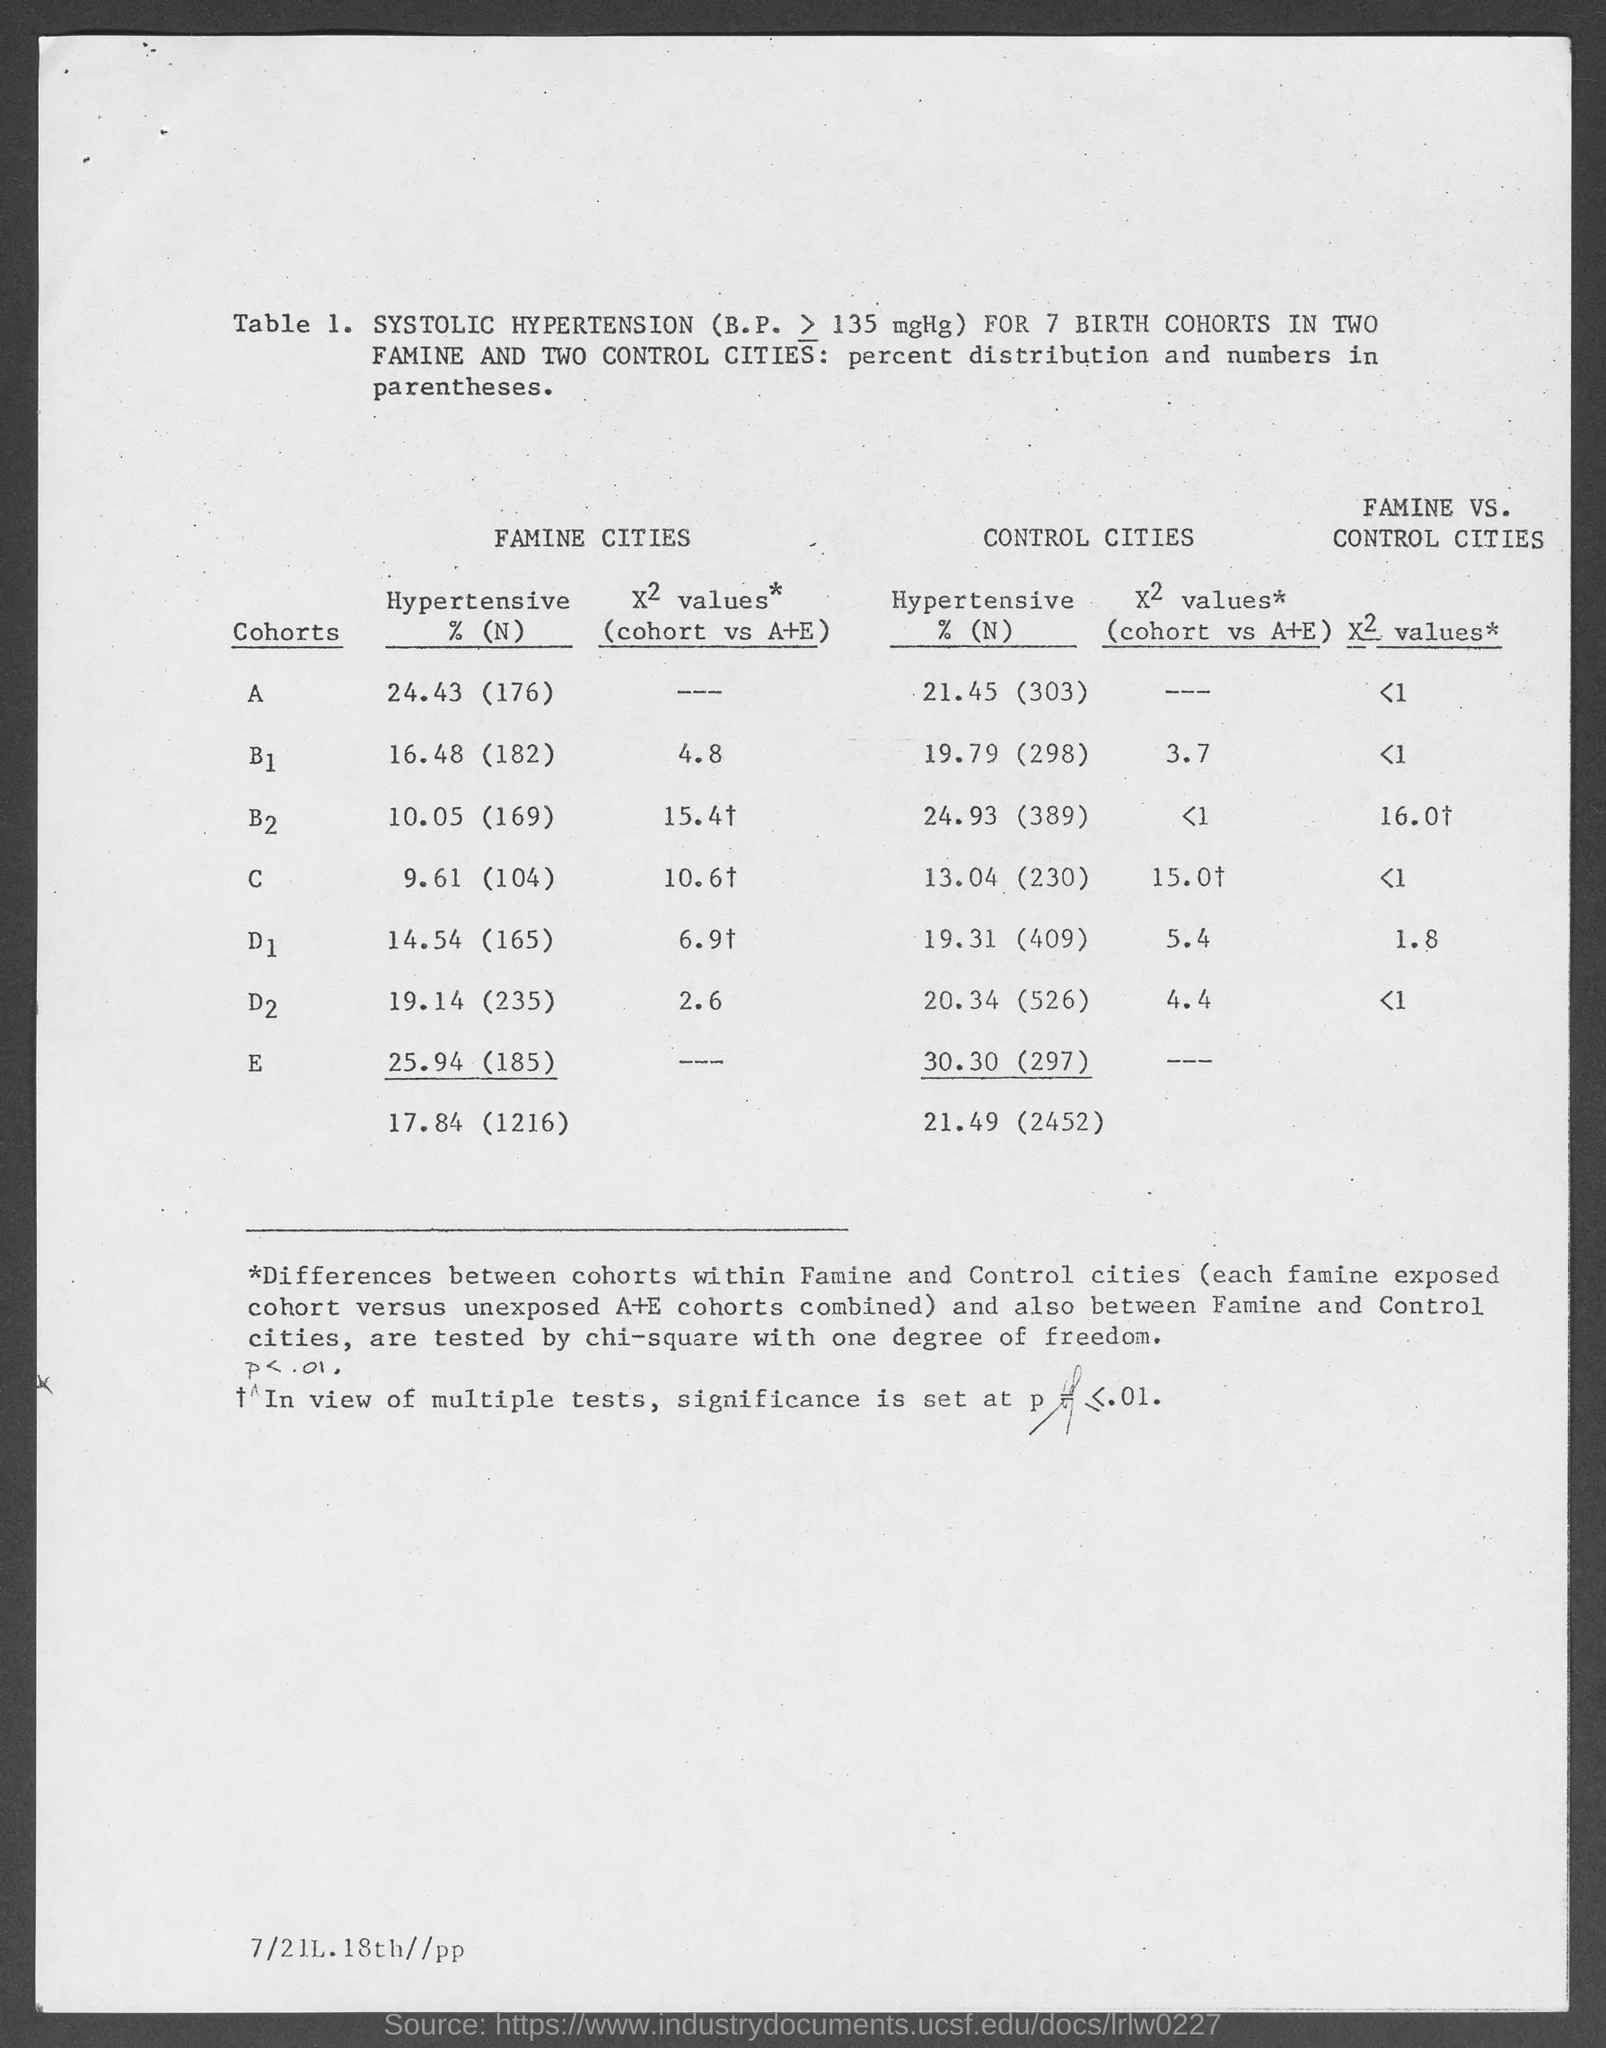What is the hypertensive %(n) value for cohorts a in famine cities  as mentioned in the given table ?
Ensure brevity in your answer.  24.43 (176). What is the hypertensive % value (n) for cohorts b1 in famine cities as mentioned in the given table ?
Offer a very short reply. 16.48 (182). What is the hypertensive % value (n) for cohorts b2 in famine cities as mentioned in the given table ?
Your response must be concise. 10.05 (169). What is the hypertensive % value (n) for cohorts c in famine cities as mentioned in the given table ?
Provide a short and direct response. 9.61 (104). What is the hypertensive % value (n) for cohorts d1 in famine cities as mentioned in the given table ?
Make the answer very short. 14.54 (165). What is the hypertensive % value (n) for cohorts d2 in famine cities as mentioned in the given table ?
Offer a terse response. 19.14 (235). What is the hypertensive % value (n) for cohorts e in famine cities as mentioned in the given table ?
Keep it short and to the point. 25.94(185). What is the hypertensive % value (n) for cohorts d2 in control cities as mentioned in the given table ?
Your answer should be compact. 20.34(526). What is the hypertensive % value (n) for cohorts b1 in control cities as mentioned in the given table ?
Your response must be concise. 19.79 (298). What is the hypertensive % value (n) for cohorts e in control cities as mentioned in the given table ?
Your response must be concise. 30.30 (297). 